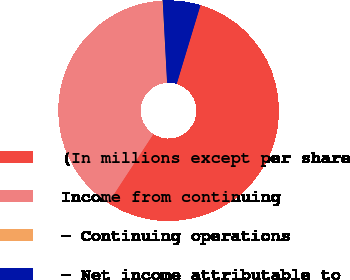Convert chart to OTSL. <chart><loc_0><loc_0><loc_500><loc_500><pie_chart><fcel>(In millions except per share<fcel>Income from continuing<fcel>- Continuing operations<fcel>- Net income attributable to<nl><fcel>54.56%<fcel>39.85%<fcel>0.07%<fcel>5.52%<nl></chart> 